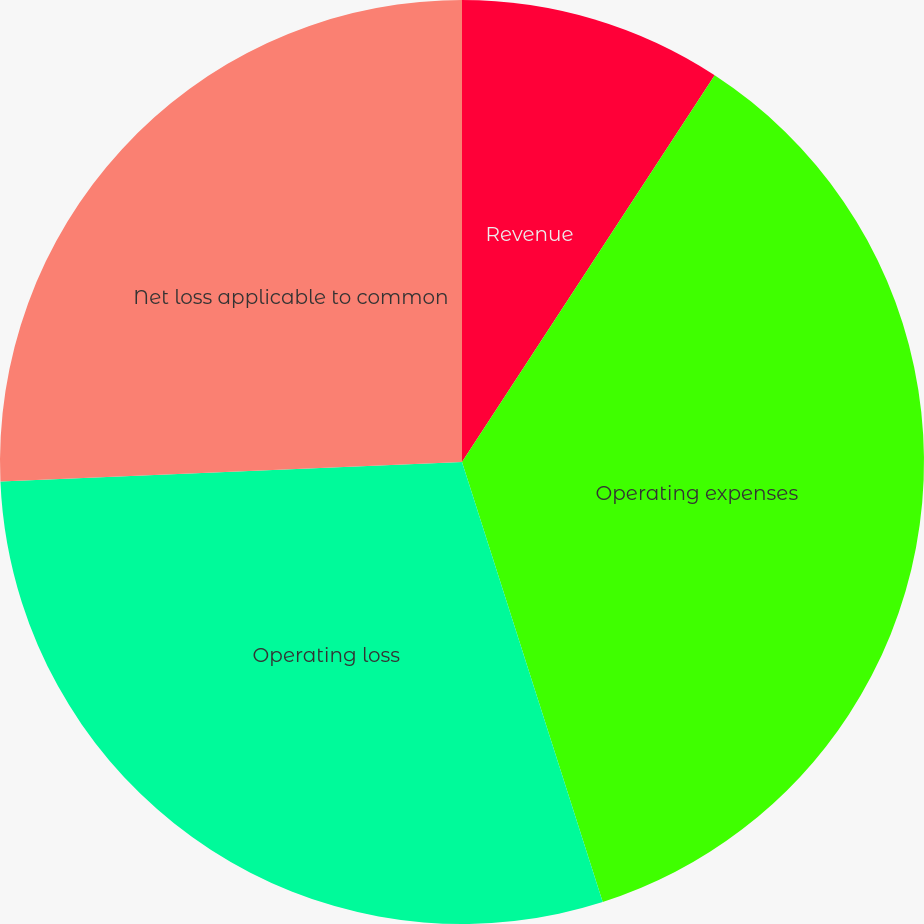Convert chart. <chart><loc_0><loc_0><loc_500><loc_500><pie_chart><fcel>Revenue<fcel>Operating expenses<fcel>Operating loss<fcel>Net loss applicable to common<fcel>Net loss per common share<nl><fcel>9.21%<fcel>35.86%<fcel>29.25%<fcel>25.67%<fcel>0.0%<nl></chart> 